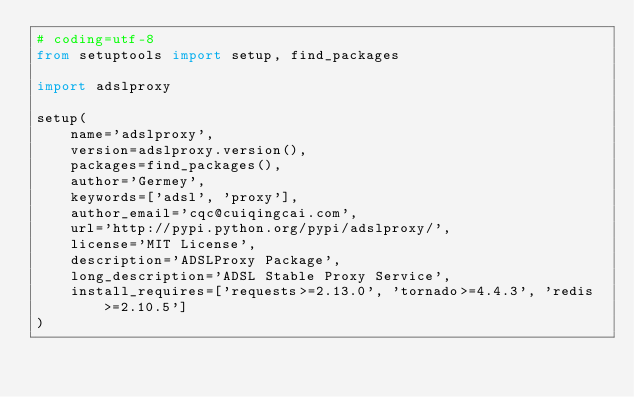<code> <loc_0><loc_0><loc_500><loc_500><_Python_># coding=utf-8
from setuptools import setup, find_packages

import adslproxy

setup(
    name='adslproxy',
    version=adslproxy.version(),
    packages=find_packages(),
    author='Germey',
    keywords=['adsl', 'proxy'],
    author_email='cqc@cuiqingcai.com',
    url='http://pypi.python.org/pypi/adslproxy/',
    license='MIT License',
    description='ADSLProxy Package',
    long_description='ADSL Stable Proxy Service',
    install_requires=['requests>=2.13.0', 'tornado>=4.4.3', 'redis>=2.10.5']
)
</code> 